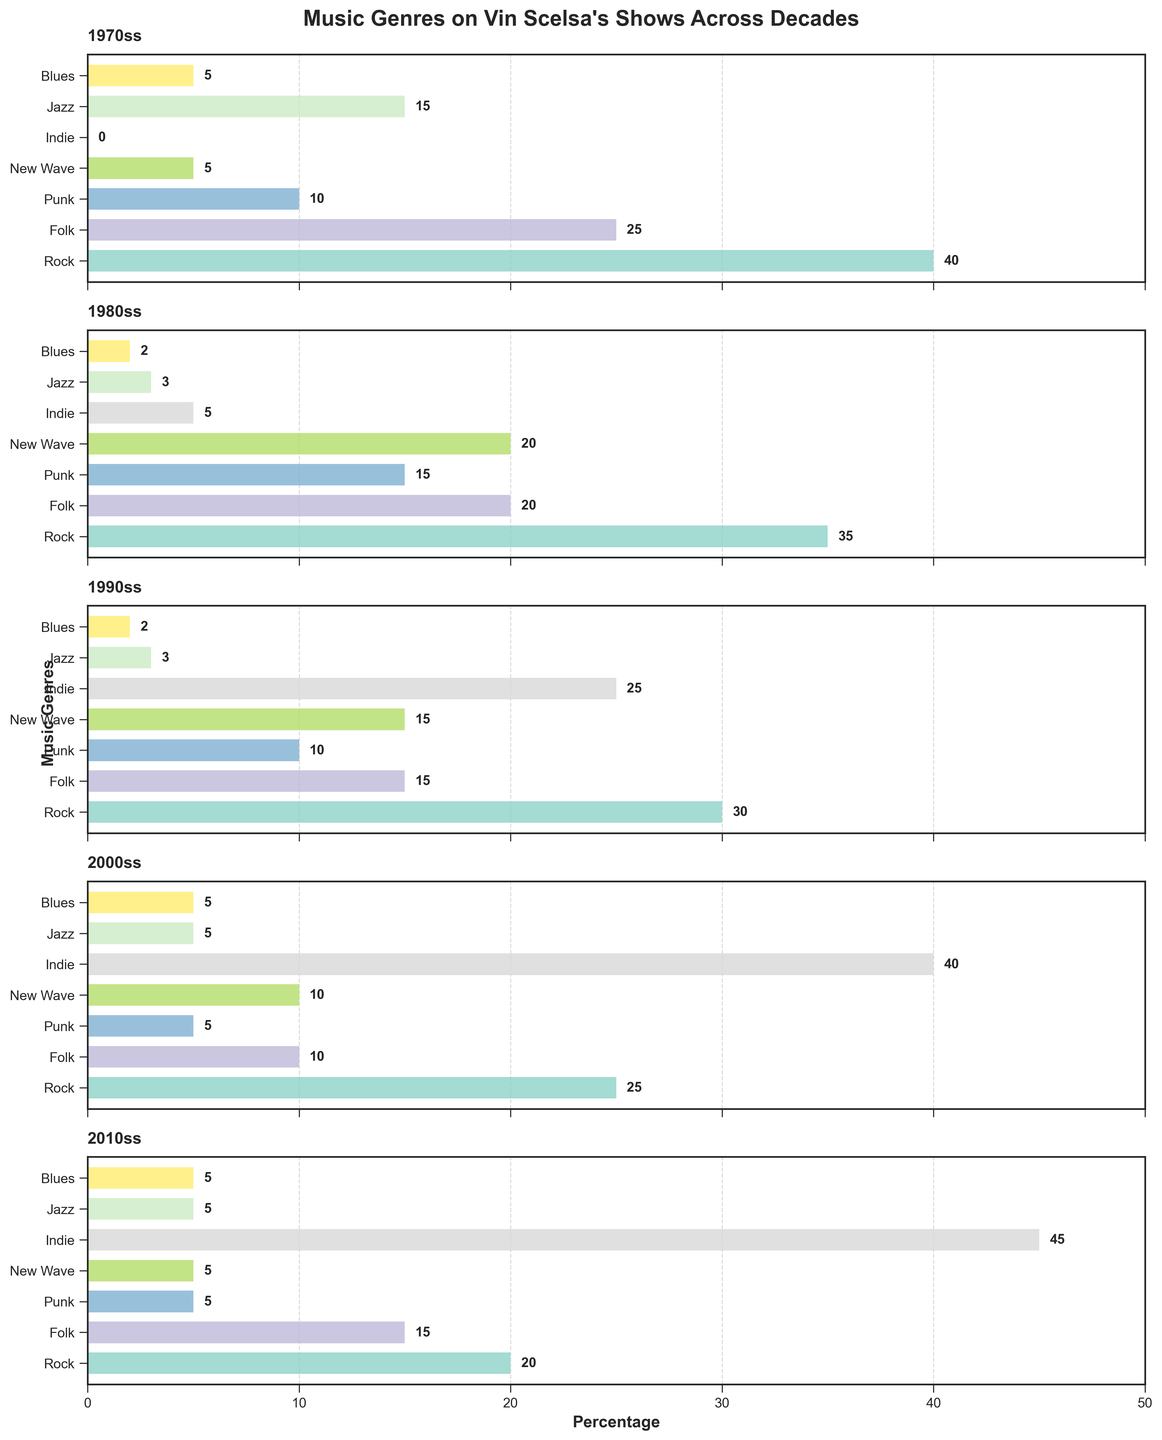What is the title of the figure? The title of a figure is typically found at the top and serves to describe the content or purpose of the chart. Here, the title is "Music Genres on Vin Scelsa's Shows Across Decades."
Answer: Music Genres on Vin Scelsa's Shows Across Decades Which decade features the highest percentage of Indie music? Look across each subplot (decade) and identify the one with the tallest bar under the Indie category. The 2010s show a 45% Indie music feature, which is the highest.
Answer: 2010s What was the trend in the percentage of Rock music from the 1970s to the 2010s? Observe the length of the Rock bars in each subplot from the 1970s to the 2010s. The bars show a decreasing trend: 40% in the 1970s, 35% in the 1980s, 30% in the 1990s, 25% in the 2000s, and 20% in the 2010s.
Answer: Decreasing What is the difference in the percentage of Folk music between the 1970s and the 2000s? Compare the percentages of Folk music in the 1970s (25%) and the 2000s (10%), and calculate the difference: 25% - 10% = 15%.
Answer: 15% Which genre had the biggest increase in percentage from the 1970s to the 2010s? Examine the bar heights for each genre in the 1970s versus the 2010s. Indie experienced the most significant increase from 0% in the 1970s to 45% in the 2010s.
Answer: Indie In which decade was Punk music featured the most? Compare the Punk bars across each decade. The 1980s have the tallest bar for Punk music at 15%.
Answer: 1980s What is the combined percentage of Jazz and Blues in the 1970s? Add the percentages of Jazz (15%) and Blues (5%) for the 1970s. The calculation is 15% + 5% = 20%.
Answer: 20% Has the percentage of New Wave music consistently increased or decreased over the decades? Analyze the New Wave bars in each subplot. The distribution is 5% in the 1970s, 20% in the 1980s, 15% in the 1990s, 10% in the 2000s, and 5% in the 2010s. The percentages have neither increased nor decreased consistently.
Answer: Neither Which genre had the smallest change in the percentage over the decades? For each genre, calculate the difference between the maximum and the minimum percentages across the decades. Blues remained quite consistent: 5% in the 1970s, 2% in the 1980s, 2% in the 1990s, 5% in the 2000s, and 5% in the 2010s, with a range of 3%.
Answer: Blues What is the overall trend for the percentage of Indie music from the 1970s to the 2010s? Observe the heights of the Indie bars. The figures show an increasing trend: 0% in the 1970s, 5% in the 1980s, 25% in the 1990s, 40% in the 2000s, and 45% in the 2010s.
Answer: Increasing 